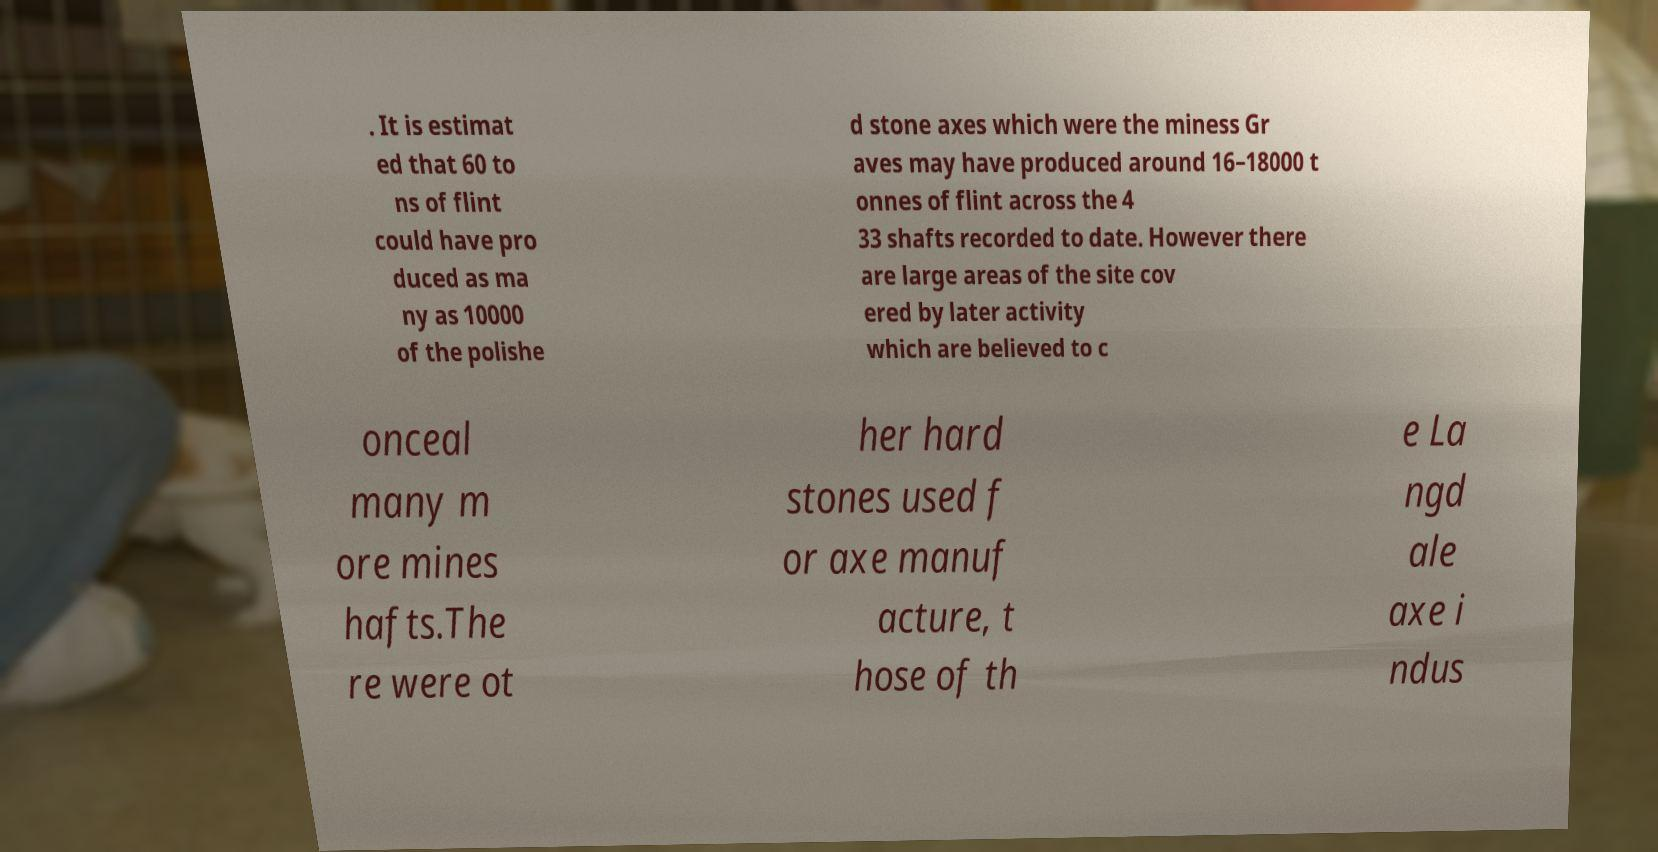Can you read and provide the text displayed in the image?This photo seems to have some interesting text. Can you extract and type it out for me? . It is estimat ed that 60 to ns of flint could have pro duced as ma ny as 10000 of the polishe d stone axes which were the miness Gr aves may have produced around 16–18000 t onnes of flint across the 4 33 shafts recorded to date. However there are large areas of the site cov ered by later activity which are believed to c onceal many m ore mines hafts.The re were ot her hard stones used f or axe manuf acture, t hose of th e La ngd ale axe i ndus 